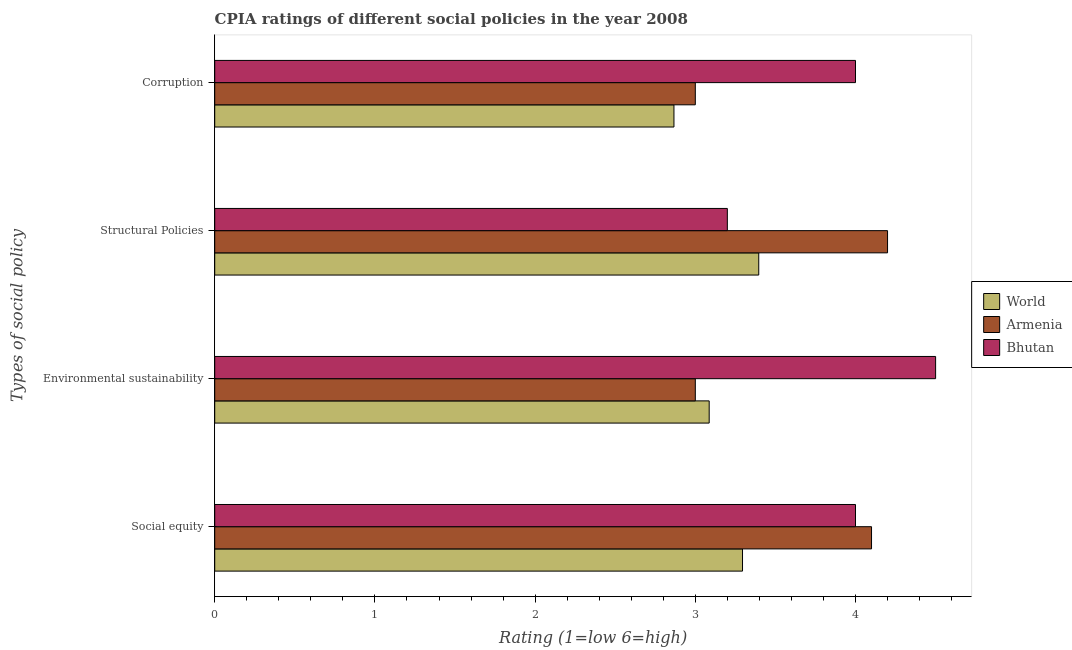Are the number of bars per tick equal to the number of legend labels?
Offer a terse response. Yes. How many bars are there on the 2nd tick from the top?
Offer a very short reply. 3. What is the label of the 1st group of bars from the top?
Make the answer very short. Corruption. What is the cpia rating of social equity in World?
Offer a very short reply. 3.29. Across all countries, what is the maximum cpia rating of social equity?
Provide a succinct answer. 4.1. Across all countries, what is the minimum cpia rating of structural policies?
Your response must be concise. 3.2. In which country was the cpia rating of structural policies maximum?
Offer a very short reply. Armenia. In which country was the cpia rating of environmental sustainability minimum?
Offer a very short reply. Armenia. What is the total cpia rating of corruption in the graph?
Give a very brief answer. 9.87. What is the difference between the cpia rating of structural policies in Armenia and that in World?
Ensure brevity in your answer.  0.8. What is the difference between the cpia rating of corruption in Bhutan and the cpia rating of social equity in Armenia?
Provide a succinct answer. -0.1. What is the average cpia rating of corruption per country?
Your answer should be compact. 3.29. What is the ratio of the cpia rating of social equity in Bhutan to that in World?
Give a very brief answer. 1.21. Is the difference between the cpia rating of social equity in World and Armenia greater than the difference between the cpia rating of environmental sustainability in World and Armenia?
Offer a very short reply. No. What is the difference between the highest and the second highest cpia rating of environmental sustainability?
Your response must be concise. 1.41. What is the difference between the highest and the lowest cpia rating of corruption?
Provide a succinct answer. 1.13. In how many countries, is the cpia rating of environmental sustainability greater than the average cpia rating of environmental sustainability taken over all countries?
Provide a succinct answer. 1. Is the sum of the cpia rating of corruption in Bhutan and World greater than the maximum cpia rating of environmental sustainability across all countries?
Ensure brevity in your answer.  Yes. What does the 1st bar from the top in Environmental sustainability represents?
Provide a succinct answer. Bhutan. What does the 2nd bar from the bottom in Structural Policies represents?
Make the answer very short. Armenia. Is it the case that in every country, the sum of the cpia rating of social equity and cpia rating of environmental sustainability is greater than the cpia rating of structural policies?
Offer a terse response. Yes. Are all the bars in the graph horizontal?
Provide a short and direct response. Yes. How many countries are there in the graph?
Offer a terse response. 3. What is the difference between two consecutive major ticks on the X-axis?
Give a very brief answer. 1. Does the graph contain any zero values?
Offer a terse response. No. Does the graph contain grids?
Your answer should be compact. No. How many legend labels are there?
Keep it short and to the point. 3. How are the legend labels stacked?
Your response must be concise. Vertical. What is the title of the graph?
Provide a succinct answer. CPIA ratings of different social policies in the year 2008. Does "Faeroe Islands" appear as one of the legend labels in the graph?
Give a very brief answer. No. What is the label or title of the X-axis?
Offer a terse response. Rating (1=low 6=high). What is the label or title of the Y-axis?
Keep it short and to the point. Types of social policy. What is the Rating (1=low 6=high) of World in Social equity?
Your answer should be compact. 3.29. What is the Rating (1=low 6=high) of Armenia in Social equity?
Offer a terse response. 4.1. What is the Rating (1=low 6=high) in Bhutan in Social equity?
Your answer should be compact. 4. What is the Rating (1=low 6=high) in World in Environmental sustainability?
Your answer should be compact. 3.09. What is the Rating (1=low 6=high) of Armenia in Environmental sustainability?
Offer a very short reply. 3. What is the Rating (1=low 6=high) in World in Structural Policies?
Make the answer very short. 3.4. What is the Rating (1=low 6=high) in Bhutan in Structural Policies?
Your response must be concise. 3.2. What is the Rating (1=low 6=high) of World in Corruption?
Give a very brief answer. 2.87. Across all Types of social policy, what is the maximum Rating (1=low 6=high) in World?
Keep it short and to the point. 3.4. Across all Types of social policy, what is the maximum Rating (1=low 6=high) of Armenia?
Make the answer very short. 4.2. Across all Types of social policy, what is the maximum Rating (1=low 6=high) in Bhutan?
Offer a terse response. 4.5. Across all Types of social policy, what is the minimum Rating (1=low 6=high) in World?
Ensure brevity in your answer.  2.87. Across all Types of social policy, what is the minimum Rating (1=low 6=high) of Bhutan?
Give a very brief answer. 3.2. What is the total Rating (1=low 6=high) in World in the graph?
Offer a very short reply. 12.64. What is the difference between the Rating (1=low 6=high) of World in Social equity and that in Environmental sustainability?
Provide a succinct answer. 0.21. What is the difference between the Rating (1=low 6=high) of World in Social equity and that in Structural Policies?
Your answer should be compact. -0.1. What is the difference between the Rating (1=low 6=high) of Bhutan in Social equity and that in Structural Policies?
Your answer should be compact. 0.8. What is the difference between the Rating (1=low 6=high) of World in Social equity and that in Corruption?
Make the answer very short. 0.43. What is the difference between the Rating (1=low 6=high) in Bhutan in Social equity and that in Corruption?
Provide a short and direct response. 0. What is the difference between the Rating (1=low 6=high) in World in Environmental sustainability and that in Structural Policies?
Keep it short and to the point. -0.31. What is the difference between the Rating (1=low 6=high) of Bhutan in Environmental sustainability and that in Structural Policies?
Offer a very short reply. 1.3. What is the difference between the Rating (1=low 6=high) in World in Environmental sustainability and that in Corruption?
Your answer should be compact. 0.22. What is the difference between the Rating (1=low 6=high) in World in Structural Policies and that in Corruption?
Your answer should be very brief. 0.53. What is the difference between the Rating (1=low 6=high) of Armenia in Structural Policies and that in Corruption?
Keep it short and to the point. 1.2. What is the difference between the Rating (1=low 6=high) in Bhutan in Structural Policies and that in Corruption?
Your response must be concise. -0.8. What is the difference between the Rating (1=low 6=high) of World in Social equity and the Rating (1=low 6=high) of Armenia in Environmental sustainability?
Make the answer very short. 0.29. What is the difference between the Rating (1=low 6=high) in World in Social equity and the Rating (1=low 6=high) in Bhutan in Environmental sustainability?
Give a very brief answer. -1.21. What is the difference between the Rating (1=low 6=high) of World in Social equity and the Rating (1=low 6=high) of Armenia in Structural Policies?
Give a very brief answer. -0.91. What is the difference between the Rating (1=low 6=high) of World in Social equity and the Rating (1=low 6=high) of Bhutan in Structural Policies?
Offer a very short reply. 0.09. What is the difference between the Rating (1=low 6=high) in Armenia in Social equity and the Rating (1=low 6=high) in Bhutan in Structural Policies?
Provide a short and direct response. 0.9. What is the difference between the Rating (1=low 6=high) in World in Social equity and the Rating (1=low 6=high) in Armenia in Corruption?
Provide a short and direct response. 0.29. What is the difference between the Rating (1=low 6=high) of World in Social equity and the Rating (1=low 6=high) of Bhutan in Corruption?
Keep it short and to the point. -0.71. What is the difference between the Rating (1=low 6=high) of World in Environmental sustainability and the Rating (1=low 6=high) of Armenia in Structural Policies?
Give a very brief answer. -1.11. What is the difference between the Rating (1=low 6=high) in World in Environmental sustainability and the Rating (1=low 6=high) in Bhutan in Structural Policies?
Make the answer very short. -0.11. What is the difference between the Rating (1=low 6=high) of World in Environmental sustainability and the Rating (1=low 6=high) of Armenia in Corruption?
Provide a succinct answer. 0.09. What is the difference between the Rating (1=low 6=high) of World in Environmental sustainability and the Rating (1=low 6=high) of Bhutan in Corruption?
Offer a terse response. -0.91. What is the difference between the Rating (1=low 6=high) of World in Structural Policies and the Rating (1=low 6=high) of Armenia in Corruption?
Offer a very short reply. 0.4. What is the difference between the Rating (1=low 6=high) in World in Structural Policies and the Rating (1=low 6=high) in Bhutan in Corruption?
Ensure brevity in your answer.  -0.6. What is the difference between the Rating (1=low 6=high) of Armenia in Structural Policies and the Rating (1=low 6=high) of Bhutan in Corruption?
Offer a very short reply. 0.2. What is the average Rating (1=low 6=high) in World per Types of social policy?
Ensure brevity in your answer.  3.16. What is the average Rating (1=low 6=high) of Armenia per Types of social policy?
Make the answer very short. 3.58. What is the average Rating (1=low 6=high) in Bhutan per Types of social policy?
Your answer should be very brief. 3.92. What is the difference between the Rating (1=low 6=high) in World and Rating (1=low 6=high) in Armenia in Social equity?
Ensure brevity in your answer.  -0.81. What is the difference between the Rating (1=low 6=high) of World and Rating (1=low 6=high) of Bhutan in Social equity?
Give a very brief answer. -0.71. What is the difference between the Rating (1=low 6=high) in Armenia and Rating (1=low 6=high) in Bhutan in Social equity?
Offer a terse response. 0.1. What is the difference between the Rating (1=low 6=high) in World and Rating (1=low 6=high) in Armenia in Environmental sustainability?
Make the answer very short. 0.09. What is the difference between the Rating (1=low 6=high) in World and Rating (1=low 6=high) in Bhutan in Environmental sustainability?
Your answer should be compact. -1.41. What is the difference between the Rating (1=low 6=high) of Armenia and Rating (1=low 6=high) of Bhutan in Environmental sustainability?
Make the answer very short. -1.5. What is the difference between the Rating (1=low 6=high) in World and Rating (1=low 6=high) in Armenia in Structural Policies?
Offer a terse response. -0.8. What is the difference between the Rating (1=low 6=high) of World and Rating (1=low 6=high) of Bhutan in Structural Policies?
Ensure brevity in your answer.  0.2. What is the difference between the Rating (1=low 6=high) of World and Rating (1=low 6=high) of Armenia in Corruption?
Ensure brevity in your answer.  -0.13. What is the difference between the Rating (1=low 6=high) of World and Rating (1=low 6=high) of Bhutan in Corruption?
Your answer should be very brief. -1.13. What is the difference between the Rating (1=low 6=high) of Armenia and Rating (1=low 6=high) of Bhutan in Corruption?
Make the answer very short. -1. What is the ratio of the Rating (1=low 6=high) of World in Social equity to that in Environmental sustainability?
Ensure brevity in your answer.  1.07. What is the ratio of the Rating (1=low 6=high) in Armenia in Social equity to that in Environmental sustainability?
Give a very brief answer. 1.37. What is the ratio of the Rating (1=low 6=high) of Bhutan in Social equity to that in Environmental sustainability?
Your response must be concise. 0.89. What is the ratio of the Rating (1=low 6=high) of World in Social equity to that in Structural Policies?
Ensure brevity in your answer.  0.97. What is the ratio of the Rating (1=low 6=high) of Armenia in Social equity to that in Structural Policies?
Ensure brevity in your answer.  0.98. What is the ratio of the Rating (1=low 6=high) in World in Social equity to that in Corruption?
Your response must be concise. 1.15. What is the ratio of the Rating (1=low 6=high) in Armenia in Social equity to that in Corruption?
Your answer should be compact. 1.37. What is the ratio of the Rating (1=low 6=high) of World in Environmental sustainability to that in Structural Policies?
Offer a terse response. 0.91. What is the ratio of the Rating (1=low 6=high) of Armenia in Environmental sustainability to that in Structural Policies?
Offer a very short reply. 0.71. What is the ratio of the Rating (1=low 6=high) in Bhutan in Environmental sustainability to that in Structural Policies?
Your answer should be very brief. 1.41. What is the ratio of the Rating (1=low 6=high) in World in Environmental sustainability to that in Corruption?
Offer a terse response. 1.08. What is the ratio of the Rating (1=low 6=high) in World in Structural Policies to that in Corruption?
Your answer should be very brief. 1.18. What is the difference between the highest and the second highest Rating (1=low 6=high) of World?
Your response must be concise. 0.1. What is the difference between the highest and the second highest Rating (1=low 6=high) in Armenia?
Offer a terse response. 0.1. What is the difference between the highest and the lowest Rating (1=low 6=high) in World?
Provide a succinct answer. 0.53. What is the difference between the highest and the lowest Rating (1=low 6=high) of Armenia?
Provide a short and direct response. 1.2. What is the difference between the highest and the lowest Rating (1=low 6=high) in Bhutan?
Your response must be concise. 1.3. 